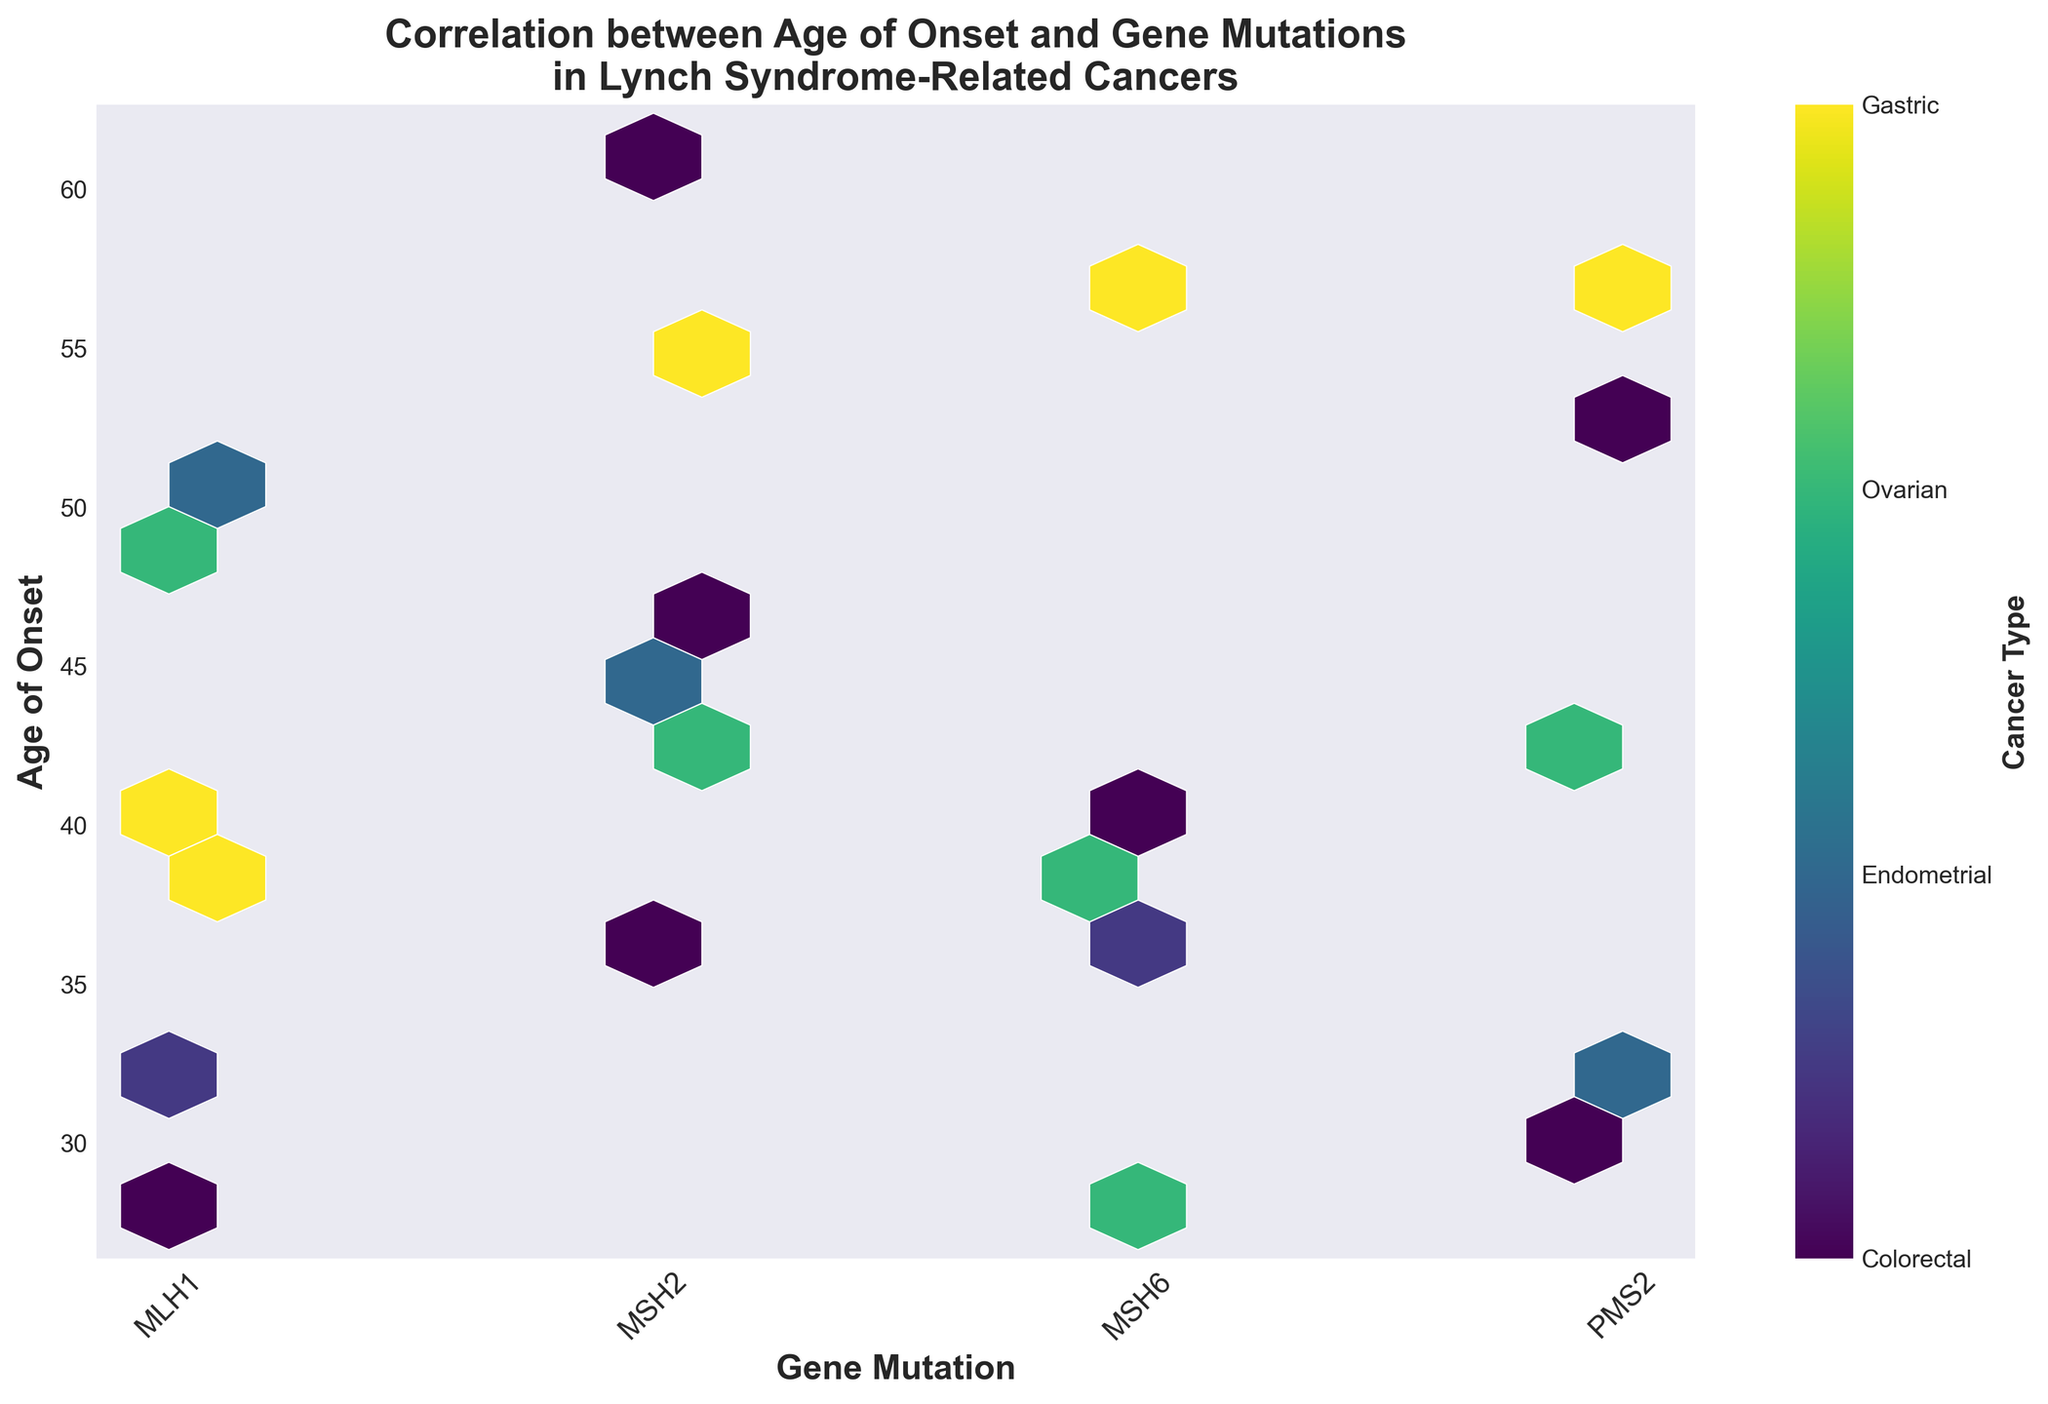What is the title of the figure? The title is prominently displayed at the top of the figure. It is "Correlation between Age of Onset and Gene Mutations in Lynch Syndrome-Related Cancers."
Answer: Correlation between Age of Onset and Gene Mutations in Lynch Syndrome-Related Cancers How are the gene mutations represented on the x-axis? The x-axis represents the different gene mutations, and it is labeled with the gene names "MLH1," "MSH2," "MSH6," and "PMS2."
Answer: MLH1, MSH2, MSH6, PMS2 Which age range shows the highest density of data points for MLH1 mutations? By observing the density of the hexagons for MLH1 mutations, the highest density seems to be around the ages 28 to 40.
Answer: 28 to 40 How is the color map used to differentiate cancer types? The color map uses shades of the 'viridis' color scheme to represent different cancer types. The color bar on the right helps to decode these colors into specific cancer types: Colorectal, Endometrial, Ovarian, and Gastric.
Answer: Different shades of the 'viridis' color bar Which gene mutation appears to have the widest age range of onset? By looking at the vertical spread of hexagons for each mutation, MLH1 appears to have the widest age range, spanning from about 28 to 50.
Answer: MLH1 What is the age of onset for the most frequent cancer type represented in the hexbin plot? One must observe the color scale and the density of the hexagons. Colorectal cancer (represented by the starting color on the color bar) shows frequent occurrences primarily in the 32 to 45 age range.
Answer: 32 to 45 How does the age of onset for MSH6 mutations compare to that of PMS2 mutations? By comparing the vertical heights of hexbins for MSH6 and PMS2, one notes that MSH6 has a higher range starting around 28 and extending to 58, while PMS2 spans slightly lower ages, around 30 to 57. Thus, MSH6 has a higher age range overall.
Answer: MSH6 has a higher age range overall Which cancer type is associated with the oldest age of onset? Looking at the top-most hexagons and cross-referencing with the color bar, Gastric cancer occurs at higher ages, specifically around 55 to 61.
Answer: Gastric cancer What can you infer about the correlation between the gene mutation PMS2 and colorectal cancer? As PMS2 has a significant number of hexagons with shades corresponding to colorectal cancer, one can infer a strong correlation between PMS2 mutations and the incidence of colorectal cancer.
Answer: Strong correlation Which gene mutation has the least apparent density regardless of age of onset? Observing the figure, MSH6 displays fewer and less dense hexagons compared to other gene mutations, indicating a relatively lower frequency in the dataset.
Answer: MSH6 